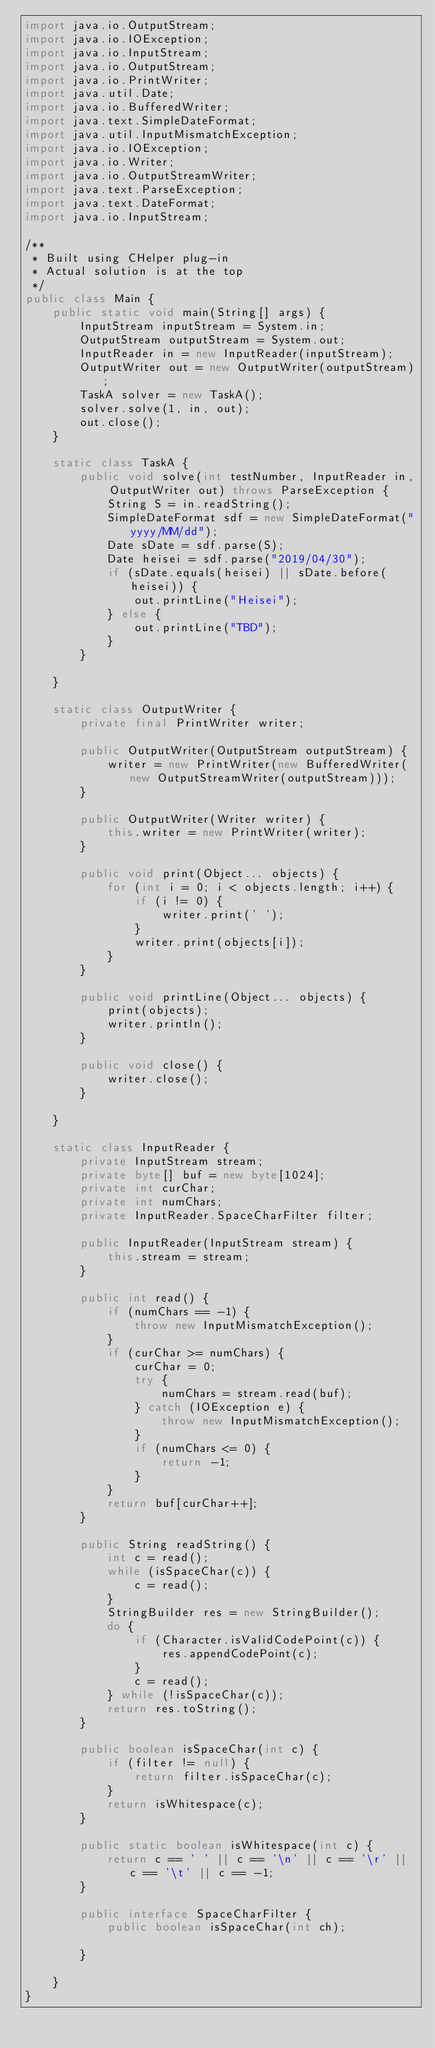<code> <loc_0><loc_0><loc_500><loc_500><_Java_>import java.io.OutputStream;
import java.io.IOException;
import java.io.InputStream;
import java.io.OutputStream;
import java.io.PrintWriter;
import java.util.Date;
import java.io.BufferedWriter;
import java.text.SimpleDateFormat;
import java.util.InputMismatchException;
import java.io.IOException;
import java.io.Writer;
import java.io.OutputStreamWriter;
import java.text.ParseException;
import java.text.DateFormat;
import java.io.InputStream;

/**
 * Built using CHelper plug-in
 * Actual solution is at the top
 */
public class Main {
    public static void main(String[] args) {
        InputStream inputStream = System.in;
        OutputStream outputStream = System.out;
        InputReader in = new InputReader(inputStream);
        OutputWriter out = new OutputWriter(outputStream);
        TaskA solver = new TaskA();
        solver.solve(1, in, out);
        out.close();
    }

    static class TaskA {
        public void solve(int testNumber, InputReader in, OutputWriter out) throws ParseException {
            String S = in.readString();
            SimpleDateFormat sdf = new SimpleDateFormat("yyyy/MM/dd");
            Date sDate = sdf.parse(S);
            Date heisei = sdf.parse("2019/04/30");
            if (sDate.equals(heisei) || sDate.before(heisei)) {
                out.printLine("Heisei");
            } else {
                out.printLine("TBD");
            }
        }

    }

    static class OutputWriter {
        private final PrintWriter writer;

        public OutputWriter(OutputStream outputStream) {
            writer = new PrintWriter(new BufferedWriter(new OutputStreamWriter(outputStream)));
        }

        public OutputWriter(Writer writer) {
            this.writer = new PrintWriter(writer);
        }

        public void print(Object... objects) {
            for (int i = 0; i < objects.length; i++) {
                if (i != 0) {
                    writer.print(' ');
                }
                writer.print(objects[i]);
            }
        }

        public void printLine(Object... objects) {
            print(objects);
            writer.println();
        }

        public void close() {
            writer.close();
        }

    }

    static class InputReader {
        private InputStream stream;
        private byte[] buf = new byte[1024];
        private int curChar;
        private int numChars;
        private InputReader.SpaceCharFilter filter;

        public InputReader(InputStream stream) {
            this.stream = stream;
        }

        public int read() {
            if (numChars == -1) {
                throw new InputMismatchException();
            }
            if (curChar >= numChars) {
                curChar = 0;
                try {
                    numChars = stream.read(buf);
                } catch (IOException e) {
                    throw new InputMismatchException();
                }
                if (numChars <= 0) {
                    return -1;
                }
            }
            return buf[curChar++];
        }

        public String readString() {
            int c = read();
            while (isSpaceChar(c)) {
                c = read();
            }
            StringBuilder res = new StringBuilder();
            do {
                if (Character.isValidCodePoint(c)) {
                    res.appendCodePoint(c);
                }
                c = read();
            } while (!isSpaceChar(c));
            return res.toString();
        }

        public boolean isSpaceChar(int c) {
            if (filter != null) {
                return filter.isSpaceChar(c);
            }
            return isWhitespace(c);
        }

        public static boolean isWhitespace(int c) {
            return c == ' ' || c == '\n' || c == '\r' || c == '\t' || c == -1;
        }

        public interface SpaceCharFilter {
            public boolean isSpaceChar(int ch);

        }

    }
}

</code> 